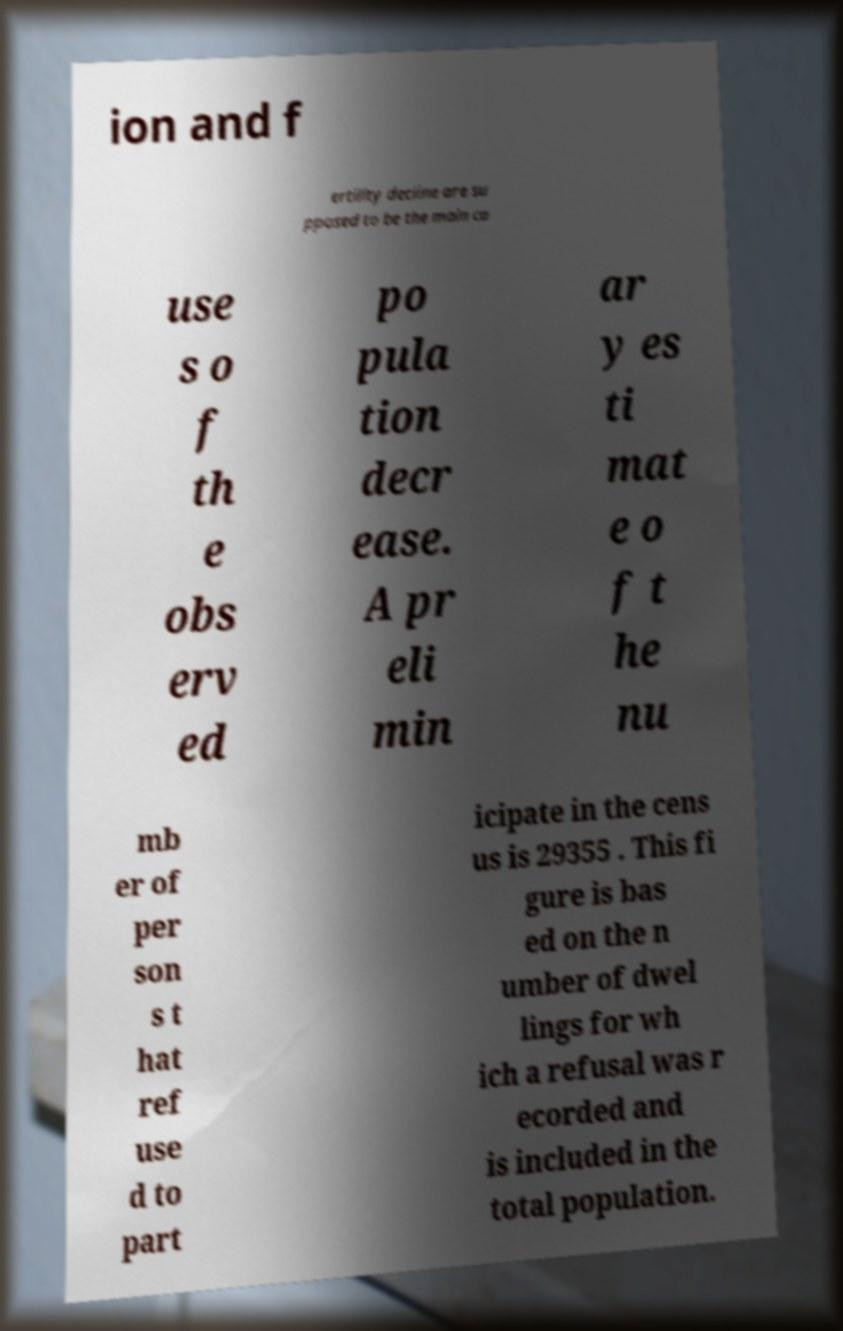What messages or text are displayed in this image? I need them in a readable, typed format. ion and f ertility decline are su pposed to be the main ca use s o f th e obs erv ed po pula tion decr ease. A pr eli min ar y es ti mat e o f t he nu mb er of per son s t hat ref use d to part icipate in the cens us is 29355 . This fi gure is bas ed on the n umber of dwel lings for wh ich a refusal was r ecorded and is included in the total population. 